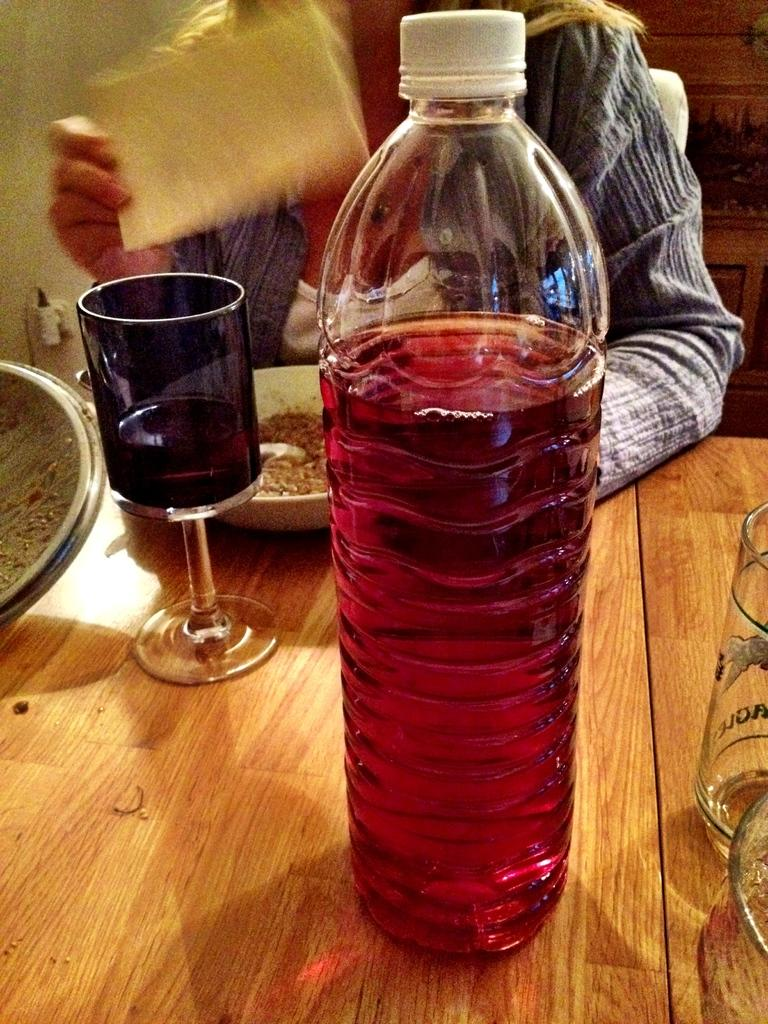What is the main piece of furniture in the image? There is a table in the image. What is on the table? There is a bottle containing red color water and a glass plate on the table. Can you describe the person in the image? There is a person sitting in the image. What type of wing is visible on the person in the image? There is no wing visible on the person in the image. What order is the person in the image following? There is no indication of an order being followed in the image. 